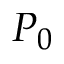Convert formula to latex. <formula><loc_0><loc_0><loc_500><loc_500>P _ { 0 }</formula> 